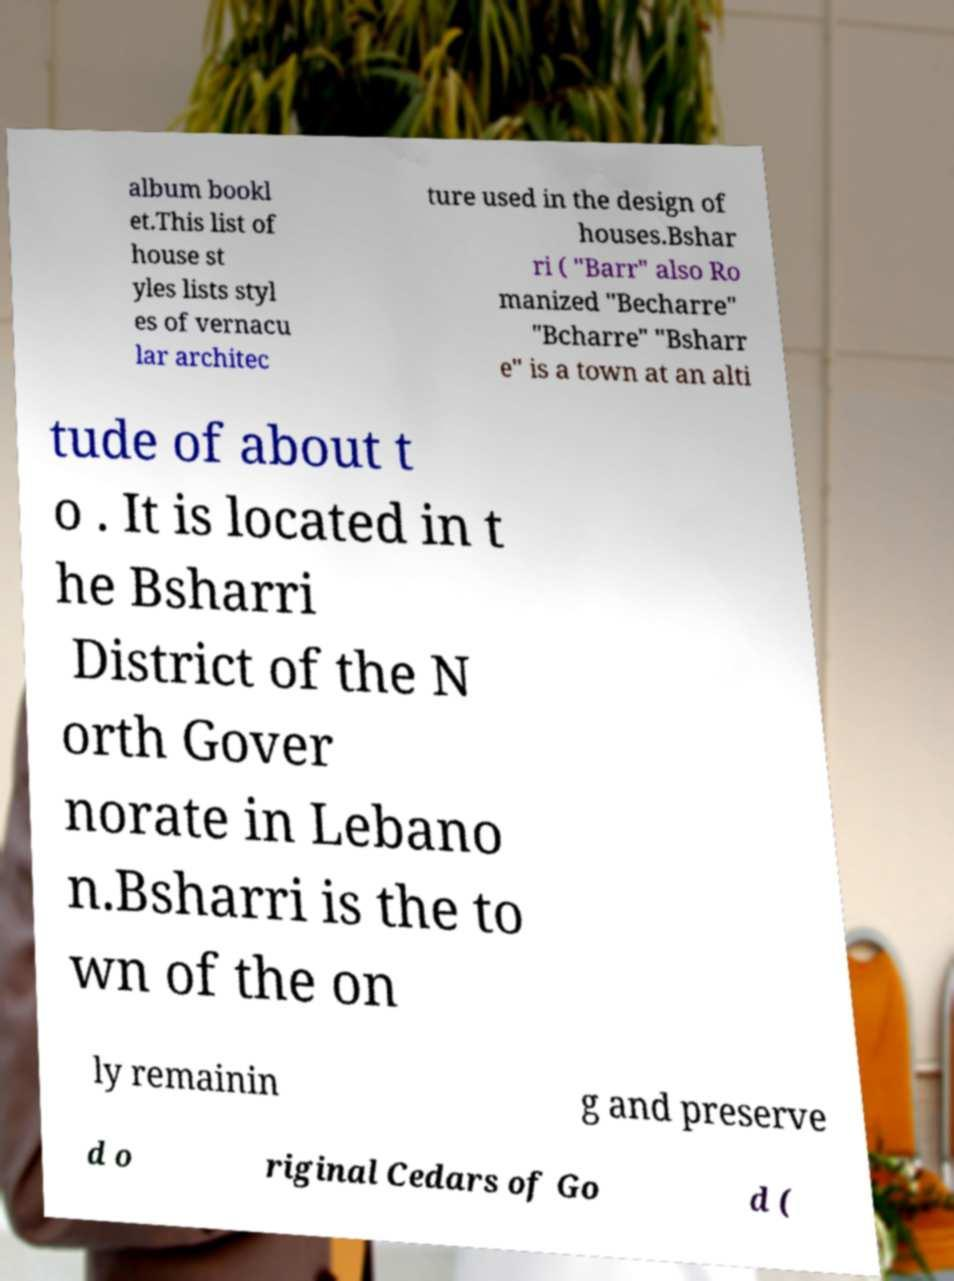Could you assist in decoding the text presented in this image and type it out clearly? album bookl et.This list of house st yles lists styl es of vernacu lar architec ture used in the design of houses.Bshar ri ( "Barr" also Ro manized "Becharre" "Bcharre" "Bsharr e" is a town at an alti tude of about t o . It is located in t he Bsharri District of the N orth Gover norate in Lebano n.Bsharri is the to wn of the on ly remainin g and preserve d o riginal Cedars of Go d ( 